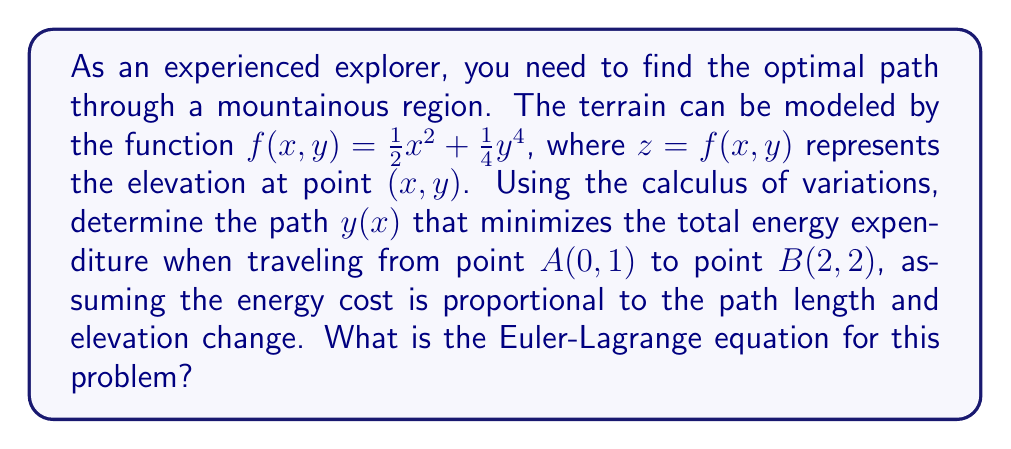Provide a solution to this math problem. To solve this problem, we'll use the calculus of variations and derive the Euler-Lagrange equation:

1. The functional to be minimized is the total energy expenditure, which is proportional to the path length and elevation change:

   $$J[y] = \int_0^2 \sqrt{1 + (y')^2 + (f_x + f_y y')^2} dx$$

   where $f_x = \frac{\partial f}{\partial x} = x$ and $f_y = \frac{\partial f}{\partial y} = y^3$.

2. Let $F(x,y,y') = \sqrt{1 + (y')^2 + (x + y^3 y')^2}$.

3. The Euler-Lagrange equation is:

   $$\frac{\partial F}{\partial y} - \frac{d}{dx}\left(\frac{\partial F}{\partial y'}\right) = 0$$

4. Calculate $\frac{\partial F}{\partial y}$:
   
   $$\frac{\partial F}{\partial y} = \frac{3y^2(x + y^3y')}{\sqrt{1 + (y')^2 + (x + y^3y')^2}}$$

5. Calculate $\frac{\partial F}{\partial y'}$:

   $$\frac{\partial F}{\partial y'} = \frac{y' + y^3(x + y^3y')}{\sqrt{1 + (y')^2 + (x + y^3y')^2}}$$

6. Calculate $\frac{d}{dx}\left(\frac{\partial F}{\partial y'}\right)$:

   This step involves complex differentiation, but the result is a function of $x$, $y$, $y'$, and $y''$.

7. Substitute the results from steps 4 and 6 into the Euler-Lagrange equation:

   $$\frac{3y^2(x + y^3y')}{\sqrt{1 + (y')^2 + (x + y^3y')^2}} - \frac{d}{dx}\left(\frac{y' + y^3(x + y^3y')}{\sqrt{1 + (y')^2 + (x + y^3y')^2}}\right) = 0$$

This is the Euler-Lagrange equation for the optimal path problem.
Answer: $$\frac{3y^2(x + y^3y')}{\sqrt{1 + (y')^2 + (x + y^3y')^2}} - \frac{d}{dx}\left(\frac{y' + y^3(x + y^3y')}{\sqrt{1 + (y')^2 + (x + y^3y')^2}}\right) = 0$$ 